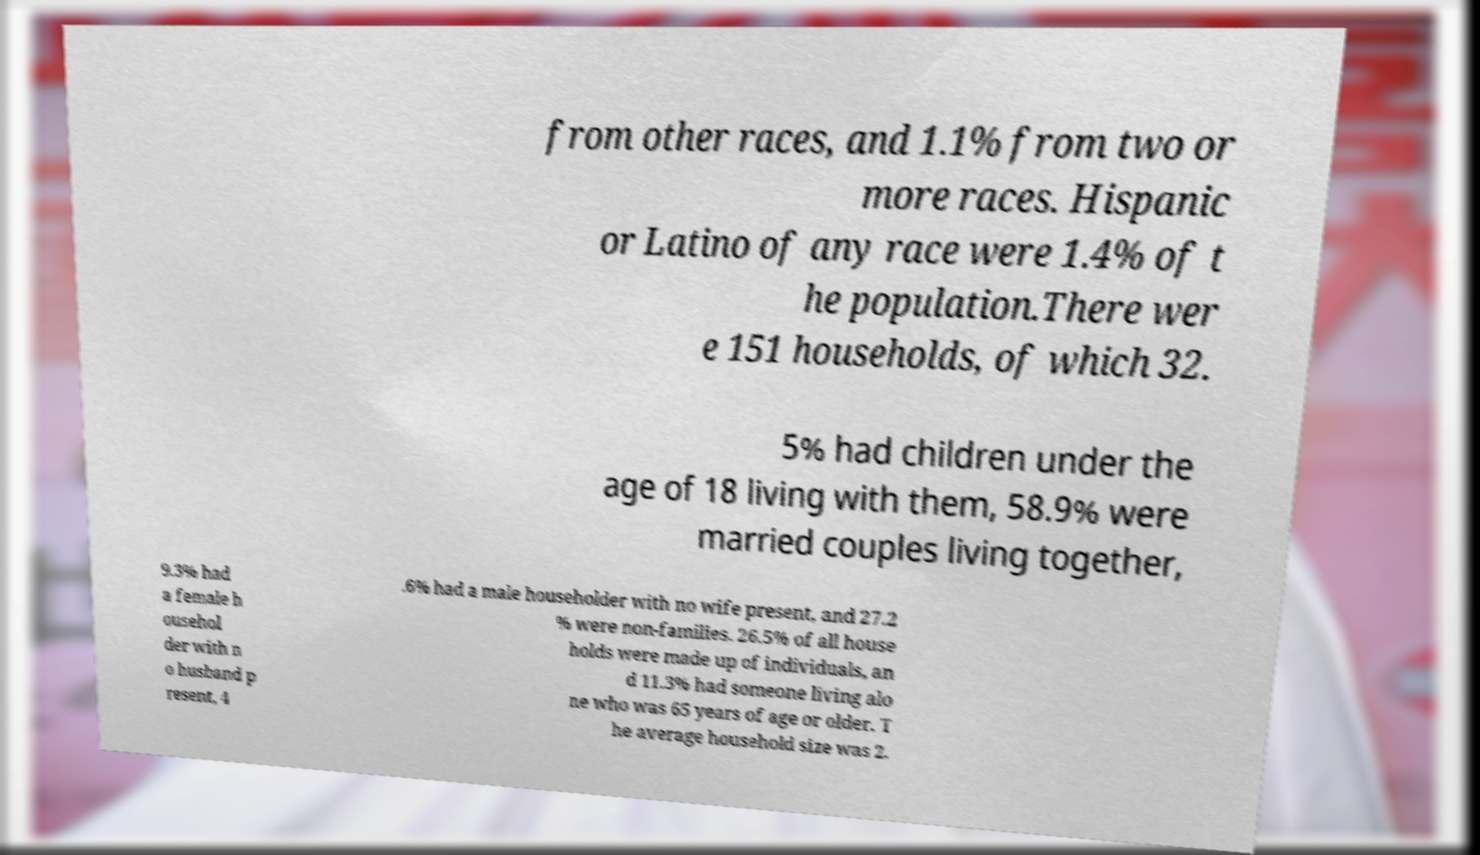Could you extract and type out the text from this image? from other races, and 1.1% from two or more races. Hispanic or Latino of any race were 1.4% of t he population.There wer e 151 households, of which 32. 5% had children under the age of 18 living with them, 58.9% were married couples living together, 9.3% had a female h ousehol der with n o husband p resent, 4 .6% had a male householder with no wife present, and 27.2 % were non-families. 26.5% of all house holds were made up of individuals, an d 11.3% had someone living alo ne who was 65 years of age or older. T he average household size was 2. 